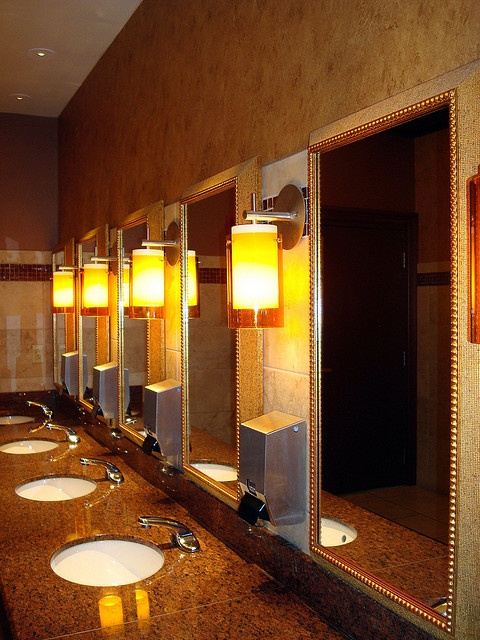Describe the objects in this image and their specific colors. I can see sink in brown, beige, tan, and darkgray tones, sink in brown, tan, and beige tones, sink in brown, tan, and olive tones, and sink in brown, gray, maroon, olive, and black tones in this image. 